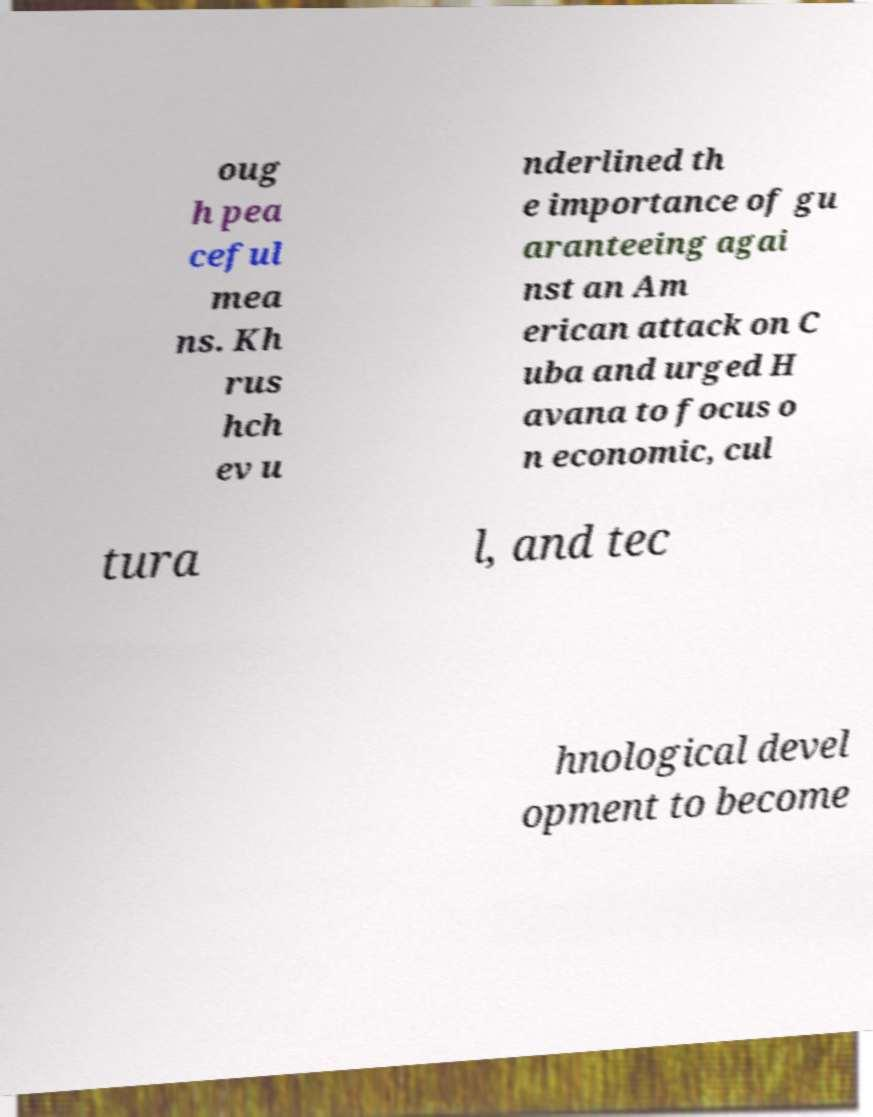Please read and relay the text visible in this image. What does it say? oug h pea ceful mea ns. Kh rus hch ev u nderlined th e importance of gu aranteeing agai nst an Am erican attack on C uba and urged H avana to focus o n economic, cul tura l, and tec hnological devel opment to become 